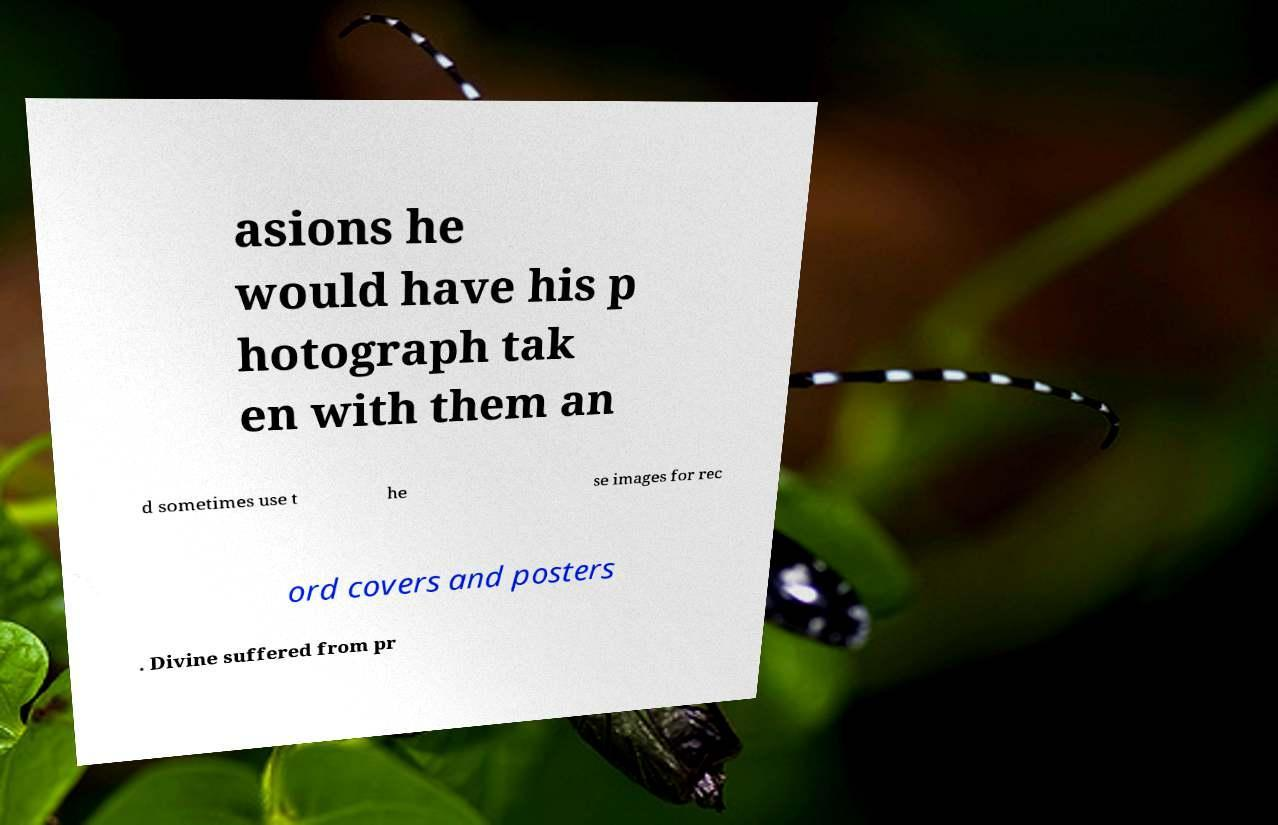Please read and relay the text visible in this image. What does it say? asions he would have his p hotograph tak en with them an d sometimes use t he se images for rec ord covers and posters . Divine suffered from pr 